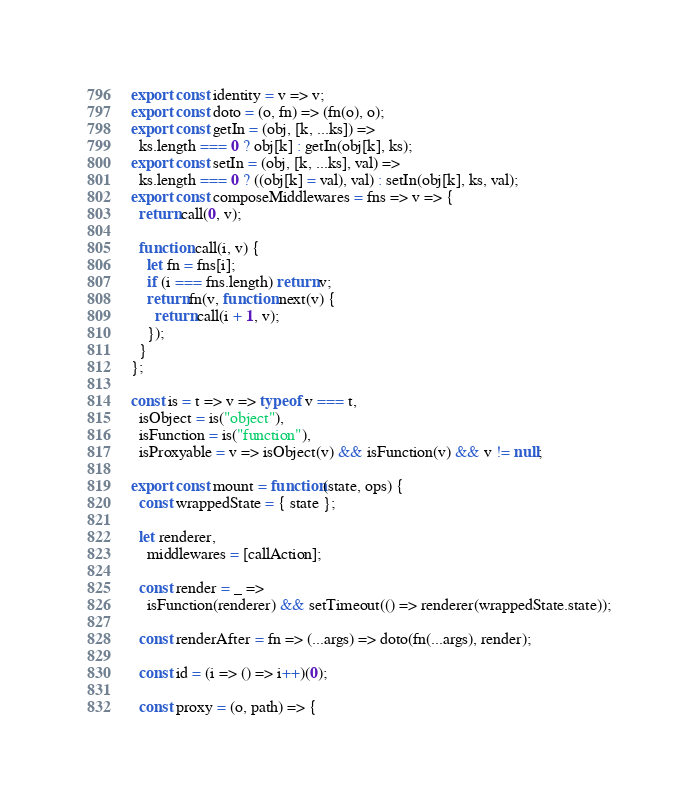<code> <loc_0><loc_0><loc_500><loc_500><_JavaScript_>export const identity = v => v;
export const doto = (o, fn) => (fn(o), o);
export const getIn = (obj, [k, ...ks]) =>
  ks.length === 0 ? obj[k] : getIn(obj[k], ks);
export const setIn = (obj, [k, ...ks], val) =>
  ks.length === 0 ? ((obj[k] = val), val) : setIn(obj[k], ks, val);
export const composeMiddlewares = fns => v => {
  return call(0, v);

  function call(i, v) {
    let fn = fns[i];
    if (i === fns.length) return v;
    return fn(v, function next(v) {
      return call(i + 1, v);
    });
  }
};

const is = t => v => typeof v === t,
  isObject = is("object"),
  isFunction = is("function"),
  isProxyable = v => isObject(v) && isFunction(v) && v != null;

export const mount = function(state, ops) {
  const wrappedState = { state };

  let renderer,
    middlewares = [callAction];

  const render = _ =>
    isFunction(renderer) && setTimeout(() => renderer(wrappedState.state));

  const renderAfter = fn => (...args) => doto(fn(...args), render);

  const id = (i => () => i++)(0);

  const proxy = (o, path) => {</code> 